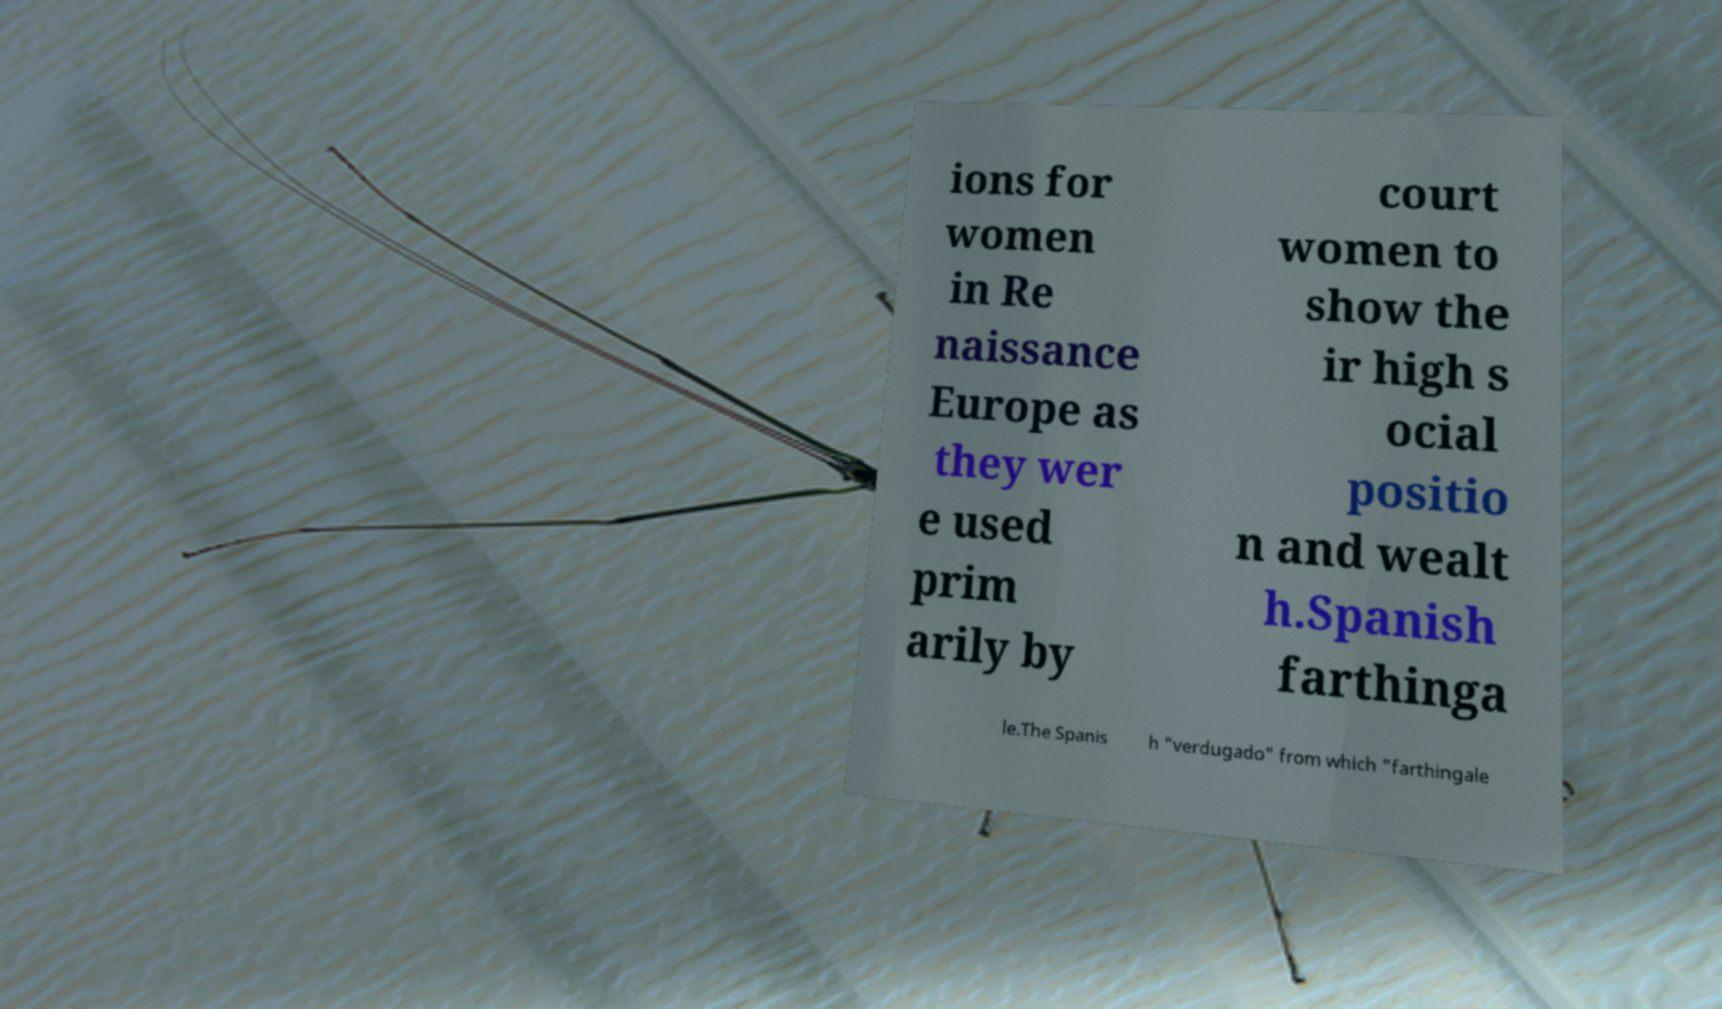I need the written content from this picture converted into text. Can you do that? ions for women in Re naissance Europe as they wer e used prim arily by court women to show the ir high s ocial positio n and wealt h.Spanish farthinga le.The Spanis h "verdugado" from which "farthingale 